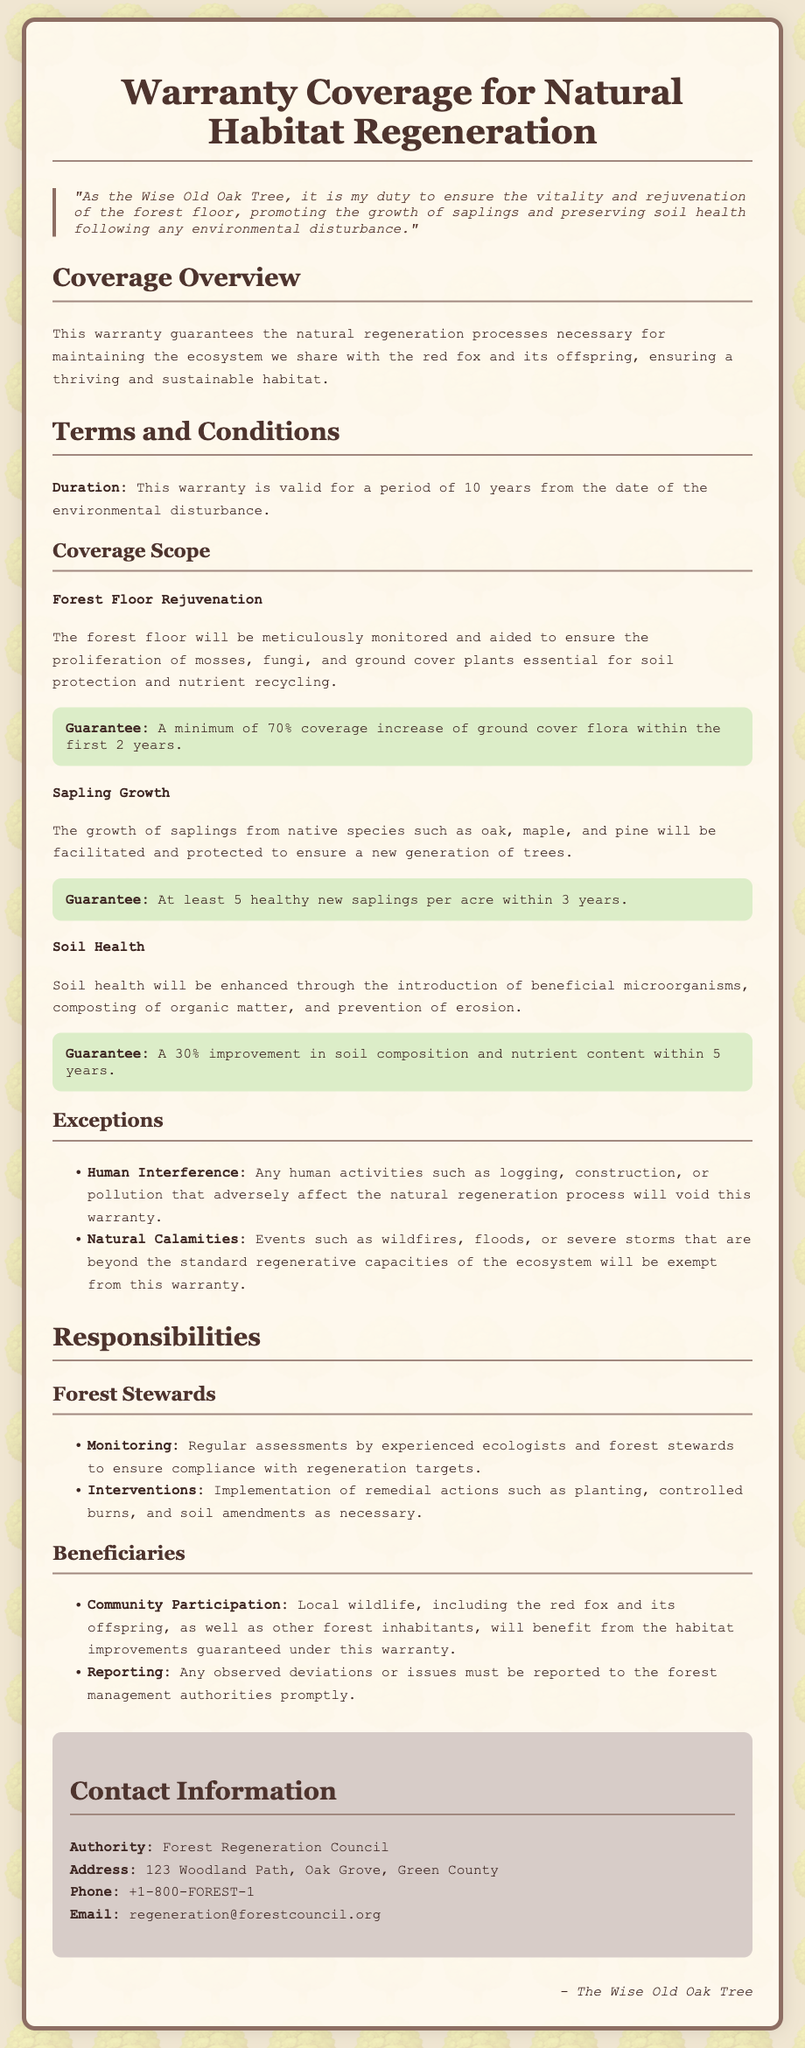What is the duration of the warranty? The warranty is valid for a period specified within the document, which states that it lasts 10 years from the date of the environmental disturbance.
Answer: 10 years What is guaranteed for the forest floor rejuvenation? The document outlines that there is a guarantee for the coverage increase of ground cover flora, detailing a minimum expected increase.
Answer: 70% coverage increase How many healthy new saplings per acre are guaranteed to grow? The warranty specifies the minimum number of new saplings that are expected to thrive, which is detailed within the coverage scope.
Answer: 5 saplings What improvements are guaranteed for soil health? The document ensures an enhancement in soil composition and nutrient content as part of the warranty's terms.
Answer: 30% improvement What types of natural calamities are exempt from the warranty? The document lists specific natural events that do not fall under the coverage of this warranty, which include certain types of disasters.
Answer: Wildfires, floods, severe storms Who is responsible for monitoring the regeneration process? Duties concerning the observation of regeneration targets are outlined, specifying the group responsible for this task.
Answer: Forest stewards What must be reported to forest management authorities? The document requires prompt reporting of specific events that indicate issues in the regeneration process, ensuring awareness and management.
Answer: Observed deviations or issues What is the contact number for the Forest Regeneration Council? The document provides direct contact information, including a phone number for inquiries related to the warranty.
Answer: +1-800-FOREST-1 